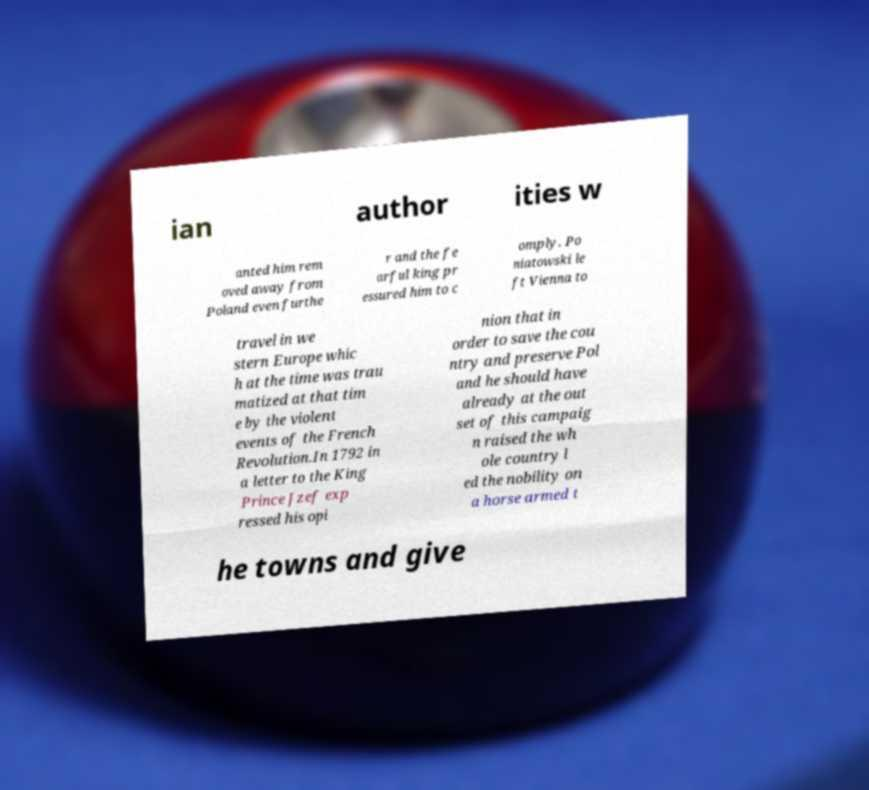Can you read and provide the text displayed in the image?This photo seems to have some interesting text. Can you extract and type it out for me? ian author ities w anted him rem oved away from Poland even furthe r and the fe arful king pr essured him to c omply. Po niatowski le ft Vienna to travel in we stern Europe whic h at the time was trau matized at that tim e by the violent events of the French Revolution.In 1792 in a letter to the King Prince Jzef exp ressed his opi nion that in order to save the cou ntry and preserve Pol and he should have already at the out set of this campaig n raised the wh ole country l ed the nobility on a horse armed t he towns and give 